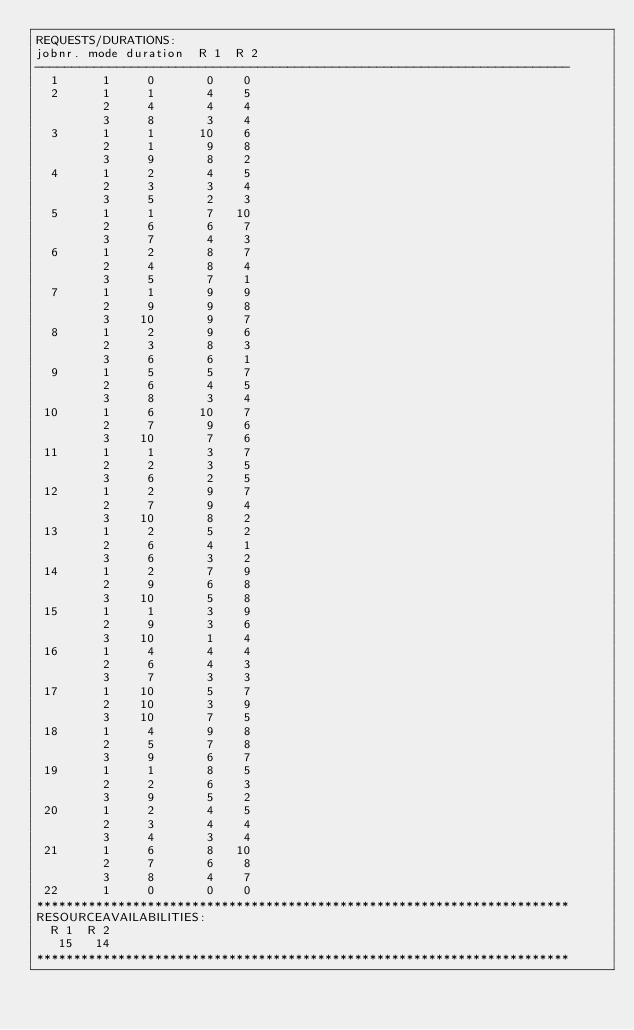Convert code to text. <code><loc_0><loc_0><loc_500><loc_500><_ObjectiveC_>REQUESTS/DURATIONS:
jobnr. mode duration  R 1  R 2
------------------------------------------------------------------------
  1      1     0       0    0
  2      1     1       4    5
         2     4       4    4
         3     8       3    4
  3      1     1      10    6
         2     1       9    8
         3     9       8    2
  4      1     2       4    5
         2     3       3    4
         3     5       2    3
  5      1     1       7   10
         2     6       6    7
         3     7       4    3
  6      1     2       8    7
         2     4       8    4
         3     5       7    1
  7      1     1       9    9
         2     9       9    8
         3    10       9    7
  8      1     2       9    6
         2     3       8    3
         3     6       6    1
  9      1     5       5    7
         2     6       4    5
         3     8       3    4
 10      1     6      10    7
         2     7       9    6
         3    10       7    6
 11      1     1       3    7
         2     2       3    5
         3     6       2    5
 12      1     2       9    7
         2     7       9    4
         3    10       8    2
 13      1     2       5    2
         2     6       4    1
         3     6       3    2
 14      1     2       7    9
         2     9       6    8
         3    10       5    8
 15      1     1       3    9
         2     9       3    6
         3    10       1    4
 16      1     4       4    4
         2     6       4    3
         3     7       3    3
 17      1    10       5    7
         2    10       3    9
         3    10       7    5
 18      1     4       9    8
         2     5       7    8
         3     9       6    7
 19      1     1       8    5
         2     2       6    3
         3     9       5    2
 20      1     2       4    5
         2     3       4    4
         3     4       3    4
 21      1     6       8   10
         2     7       6    8
         3     8       4    7
 22      1     0       0    0
************************************************************************
RESOURCEAVAILABILITIES:
  R 1  R 2
   15   14
************************************************************************
</code> 